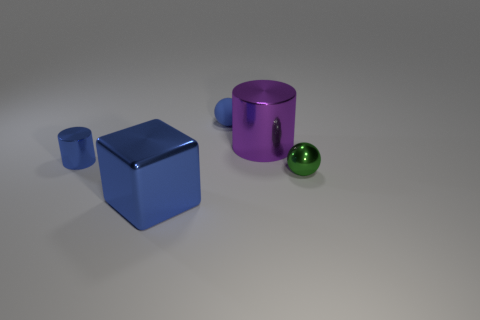Add 5 large purple spheres. How many objects exist? 10 Subtract all cubes. How many objects are left? 4 Add 3 big metal things. How many big metal things are left? 5 Add 5 small metal spheres. How many small metal spheres exist? 6 Subtract 0 brown cylinders. How many objects are left? 5 Subtract all tiny green rubber spheres. Subtract all big blue metallic cubes. How many objects are left? 4 